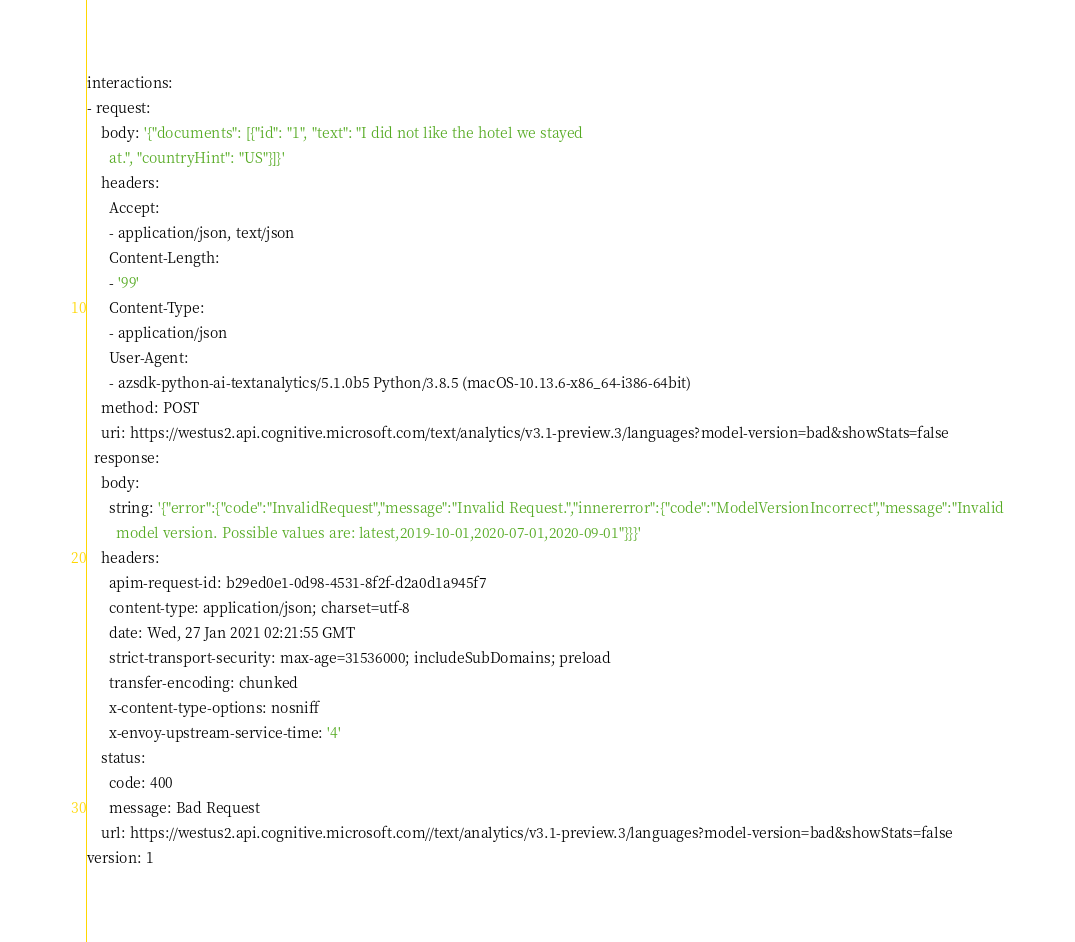<code> <loc_0><loc_0><loc_500><loc_500><_YAML_>interactions:
- request:
    body: '{"documents": [{"id": "1", "text": "I did not like the hotel we stayed
      at.", "countryHint": "US"}]}'
    headers:
      Accept:
      - application/json, text/json
      Content-Length:
      - '99'
      Content-Type:
      - application/json
      User-Agent:
      - azsdk-python-ai-textanalytics/5.1.0b5 Python/3.8.5 (macOS-10.13.6-x86_64-i386-64bit)
    method: POST
    uri: https://westus2.api.cognitive.microsoft.com/text/analytics/v3.1-preview.3/languages?model-version=bad&showStats=false
  response:
    body:
      string: '{"error":{"code":"InvalidRequest","message":"Invalid Request.","innererror":{"code":"ModelVersionIncorrect","message":"Invalid
        model version. Possible values are: latest,2019-10-01,2020-07-01,2020-09-01"}}}'
    headers:
      apim-request-id: b29ed0e1-0d98-4531-8f2f-d2a0d1a945f7
      content-type: application/json; charset=utf-8
      date: Wed, 27 Jan 2021 02:21:55 GMT
      strict-transport-security: max-age=31536000; includeSubDomains; preload
      transfer-encoding: chunked
      x-content-type-options: nosniff
      x-envoy-upstream-service-time: '4'
    status:
      code: 400
      message: Bad Request
    url: https://westus2.api.cognitive.microsoft.com//text/analytics/v3.1-preview.3/languages?model-version=bad&showStats=false
version: 1
</code> 